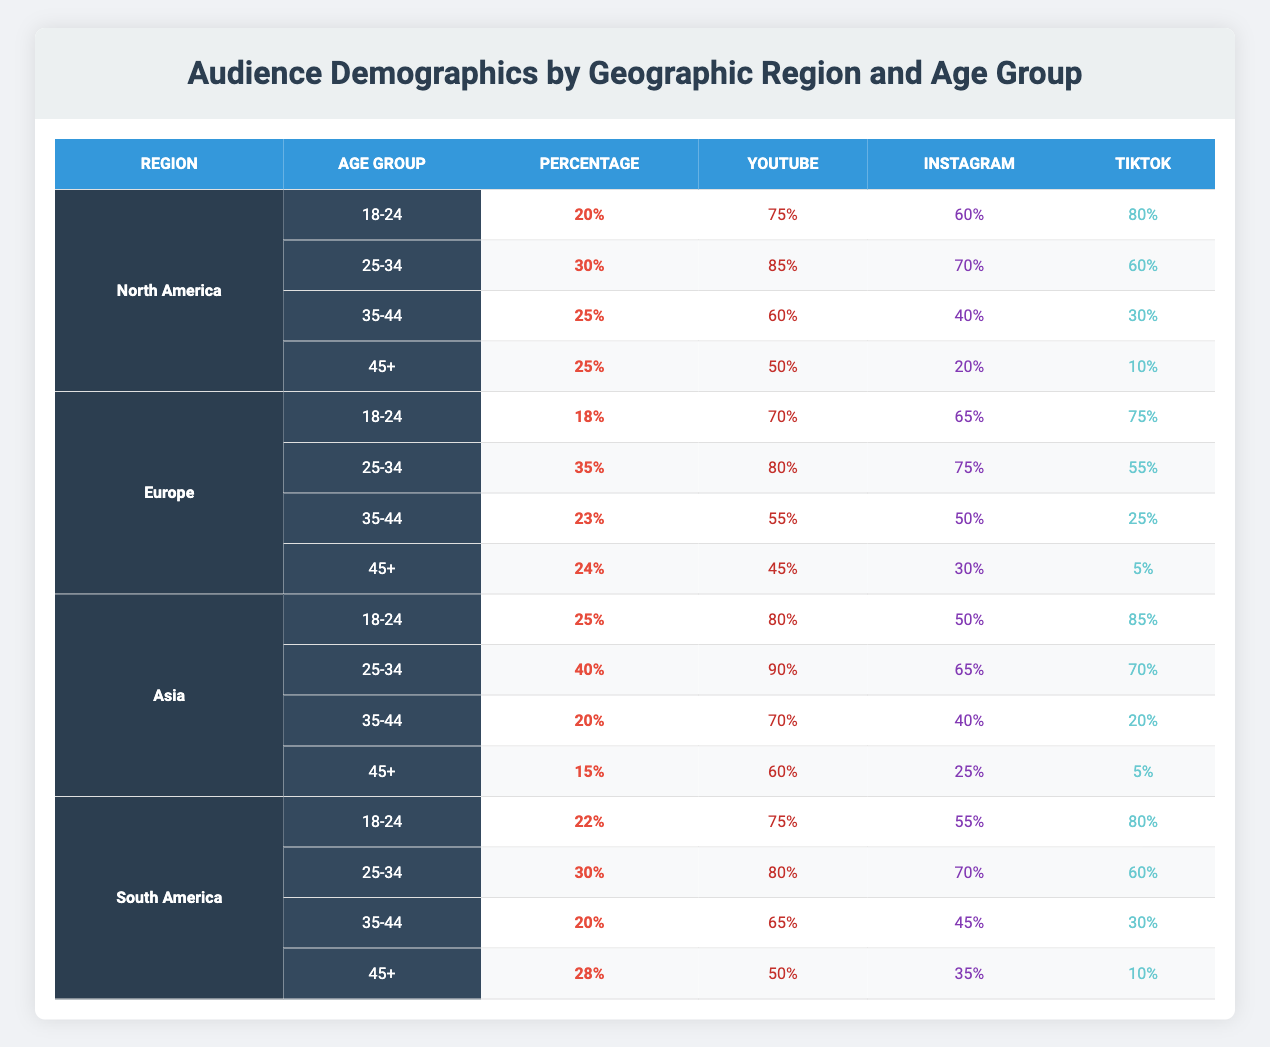What percentage of the audience in North America is aged 25-34? In the table, under the North America region, the age group 25-34 has a corresponding percentage value of 30%.
Answer: 30% Which platform has the highest audience percentage in Asia for the 18-24 age group? In Asia, for the 18-24 age group, the platform percentages are: YouTube (80%), Instagram (50%), and TikTok (85%). The highest value is for TikTok at 85%.
Answer: TikTok What is the total percentage of the audience aged 45+ in South America? The age group 45+ in South America has a percentage of 28%. This is the only data needed since the question only asks for that specific group.
Answer: 28% Is the audience percentage for the 35-44 age group higher in North America or Europe? The percentage for the 35-44 age group in North America is 25%, while in Europe it is 23%. Therefore, it is higher in North America.
Answer: Yes What is the average percentage of audiences aged 18-24 across all geographic regions? The percentages for the age group 18-24 are: North America (20%), Europe (18%), Asia (25%), and South America (22%). To find the average, we sum these values: 20 + 18 + 25 + 22 = 85, then divide by 4 (the number of regions), which gives us 85 / 4 = 21.25.
Answer: 21.25 What is the difference in the percentage of TikTok audiences for the age group 25-34 between Asia and Europe? For Asia, the percentage of TikTok audiences aged 25-34 is 70%, and for Europe, it is 55%. The difference is calculated as 70% - 55% = 15%.
Answer: 15% Which region has the lowest percentage of audience for the 45+ age group? By examining the percentages for age group 45+, we find: North America (25%), Europe (24%), Asia (15%), and South America (28%). The lowest percentage is from Asia at 15%.
Answer: Asia Does North America have a higher percentage of the audience aged 18-24 compared to South America? North America has 20% in the 18-24 age group, while South America has 22%. Since 22% is greater than 20%, North America does not have a higher percentage.
Answer: No What is the total percentage of audience aged 35-44 across all regions? The percentages for the age group 35-44 are: North America (25%), Europe (23%), Asia (20%), and South America (20%). Adding these: 25 + 23 + 20 + 20 = 88.
Answer: 88 